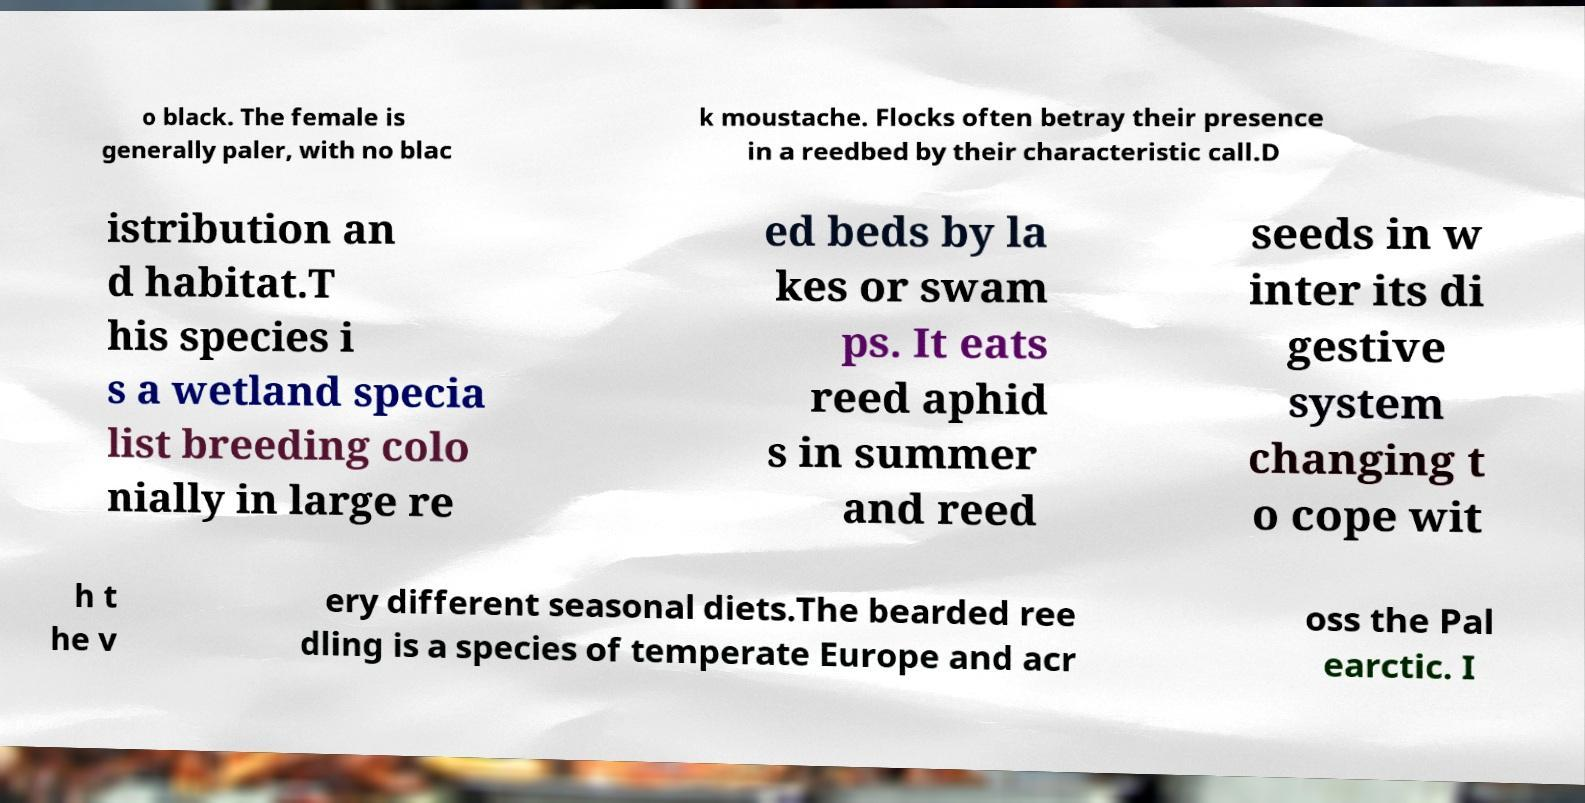Can you accurately transcribe the text from the provided image for me? o black. The female is generally paler, with no blac k moustache. Flocks often betray their presence in a reedbed by their characteristic call.D istribution an d habitat.T his species i s a wetland specia list breeding colo nially in large re ed beds by la kes or swam ps. It eats reed aphid s in summer and reed seeds in w inter its di gestive system changing t o cope wit h t he v ery different seasonal diets.The bearded ree dling is a species of temperate Europe and acr oss the Pal earctic. I 